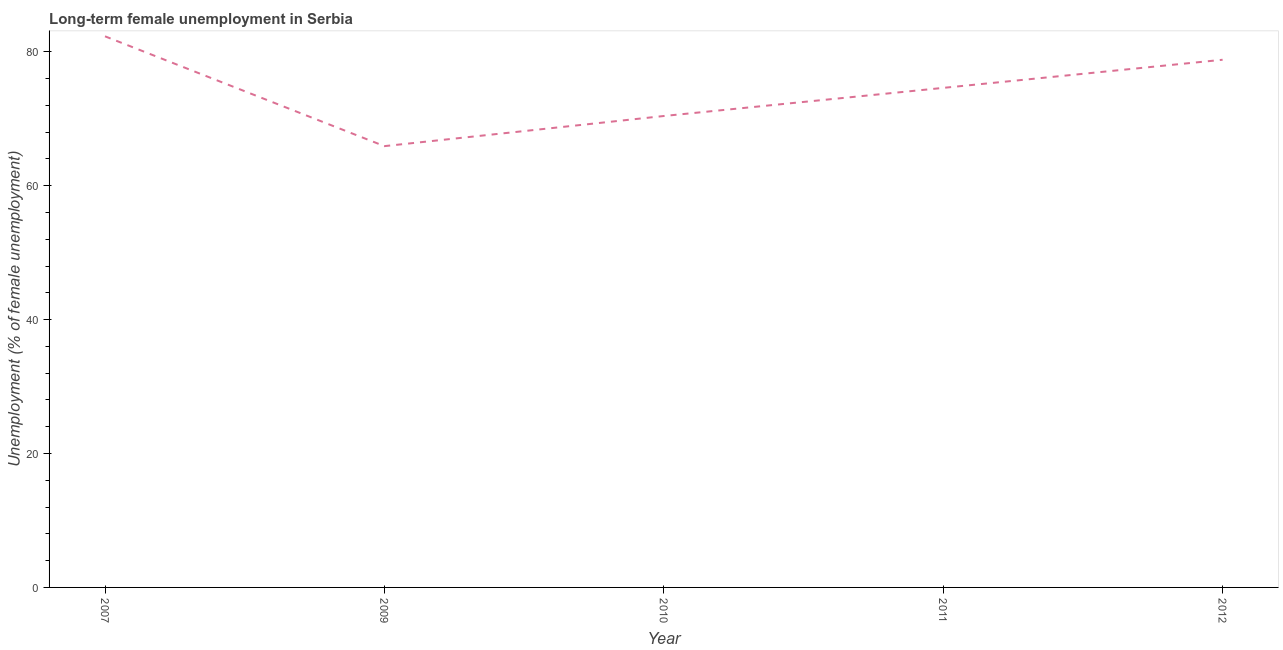What is the long-term female unemployment in 2010?
Keep it short and to the point. 70.4. Across all years, what is the maximum long-term female unemployment?
Ensure brevity in your answer.  82.3. Across all years, what is the minimum long-term female unemployment?
Your answer should be very brief. 65.9. In which year was the long-term female unemployment minimum?
Ensure brevity in your answer.  2009. What is the sum of the long-term female unemployment?
Provide a succinct answer. 372. What is the difference between the long-term female unemployment in 2010 and 2011?
Offer a terse response. -4.2. What is the average long-term female unemployment per year?
Offer a terse response. 74.4. What is the median long-term female unemployment?
Provide a short and direct response. 74.6. In how many years, is the long-term female unemployment greater than 72 %?
Make the answer very short. 3. What is the ratio of the long-term female unemployment in 2009 to that in 2010?
Your response must be concise. 0.94. Is the long-term female unemployment in 2007 less than that in 2009?
Your answer should be compact. No. What is the difference between the highest and the second highest long-term female unemployment?
Provide a succinct answer. 3.5. What is the difference between the highest and the lowest long-term female unemployment?
Make the answer very short. 16.4. Does the long-term female unemployment monotonically increase over the years?
Keep it short and to the point. No. How many lines are there?
Your response must be concise. 1. How many years are there in the graph?
Provide a short and direct response. 5. Does the graph contain any zero values?
Offer a very short reply. No. Does the graph contain grids?
Your response must be concise. No. What is the title of the graph?
Provide a short and direct response. Long-term female unemployment in Serbia. What is the label or title of the Y-axis?
Make the answer very short. Unemployment (% of female unemployment). What is the Unemployment (% of female unemployment) of 2007?
Provide a short and direct response. 82.3. What is the Unemployment (% of female unemployment) in 2009?
Your response must be concise. 65.9. What is the Unemployment (% of female unemployment) of 2010?
Offer a terse response. 70.4. What is the Unemployment (% of female unemployment) in 2011?
Keep it short and to the point. 74.6. What is the Unemployment (% of female unemployment) of 2012?
Give a very brief answer. 78.8. What is the difference between the Unemployment (% of female unemployment) in 2007 and 2009?
Ensure brevity in your answer.  16.4. What is the difference between the Unemployment (% of female unemployment) in 2007 and 2010?
Keep it short and to the point. 11.9. What is the difference between the Unemployment (% of female unemployment) in 2007 and 2012?
Offer a terse response. 3.5. What is the difference between the Unemployment (% of female unemployment) in 2009 and 2010?
Your answer should be very brief. -4.5. What is the difference between the Unemployment (% of female unemployment) in 2009 and 2011?
Ensure brevity in your answer.  -8.7. What is the difference between the Unemployment (% of female unemployment) in 2010 and 2011?
Your answer should be very brief. -4.2. What is the difference between the Unemployment (% of female unemployment) in 2010 and 2012?
Your response must be concise. -8.4. What is the ratio of the Unemployment (% of female unemployment) in 2007 to that in 2009?
Make the answer very short. 1.25. What is the ratio of the Unemployment (% of female unemployment) in 2007 to that in 2010?
Keep it short and to the point. 1.17. What is the ratio of the Unemployment (% of female unemployment) in 2007 to that in 2011?
Make the answer very short. 1.1. What is the ratio of the Unemployment (% of female unemployment) in 2007 to that in 2012?
Your response must be concise. 1.04. What is the ratio of the Unemployment (% of female unemployment) in 2009 to that in 2010?
Offer a very short reply. 0.94. What is the ratio of the Unemployment (% of female unemployment) in 2009 to that in 2011?
Offer a very short reply. 0.88. What is the ratio of the Unemployment (% of female unemployment) in 2009 to that in 2012?
Your answer should be compact. 0.84. What is the ratio of the Unemployment (% of female unemployment) in 2010 to that in 2011?
Offer a very short reply. 0.94. What is the ratio of the Unemployment (% of female unemployment) in 2010 to that in 2012?
Your answer should be compact. 0.89. What is the ratio of the Unemployment (% of female unemployment) in 2011 to that in 2012?
Your response must be concise. 0.95. 